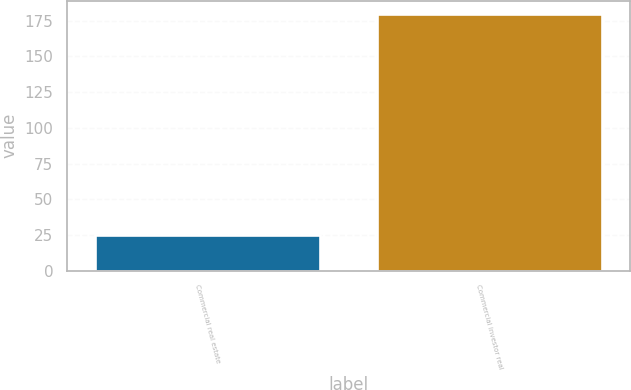<chart> <loc_0><loc_0><loc_500><loc_500><bar_chart><fcel>Commercial real estate<fcel>Commercial investor real<nl><fcel>25<fcel>180<nl></chart> 